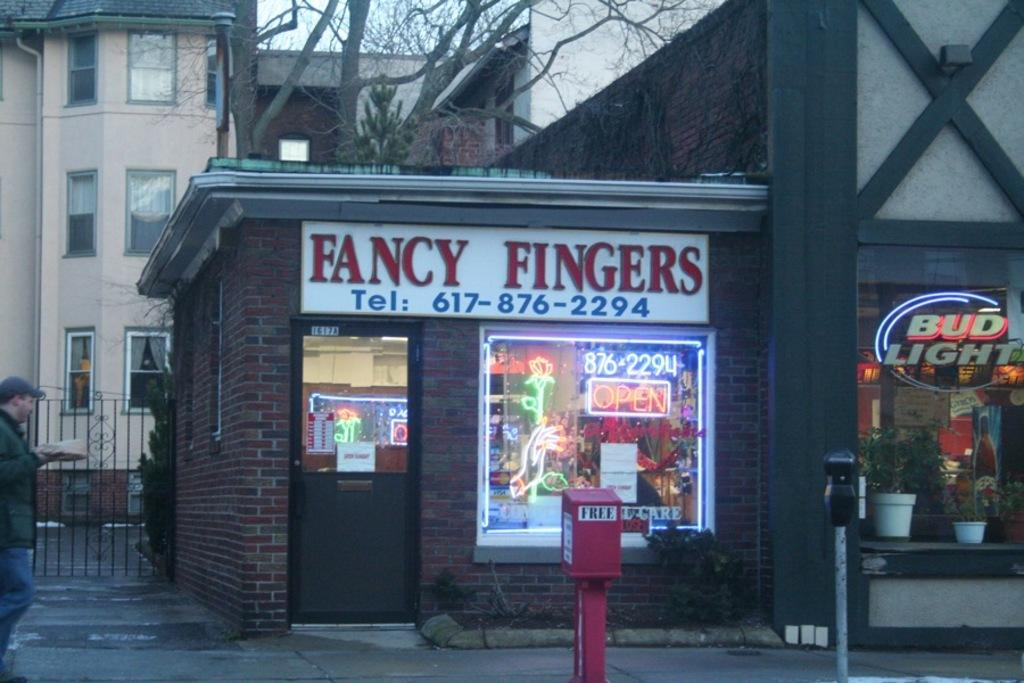Provide a one-sentence caption for the provided image. A small shop called Fancy Fingers that is attached to a larger shop. 